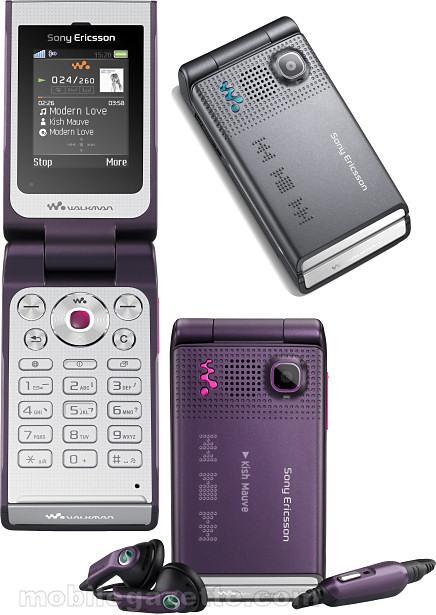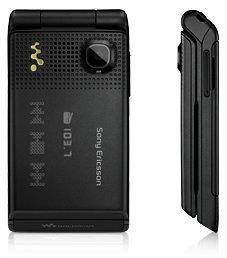The first image is the image on the left, the second image is the image on the right. Assess this claim about the two images: "Exactly one flip phone is open.". Correct or not? Answer yes or no. Yes. The first image is the image on the left, the second image is the image on the right. For the images shown, is this caption "There is an open flip phone in the image on the left." true? Answer yes or no. Yes. 